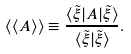Convert formula to latex. <formula><loc_0><loc_0><loc_500><loc_500>\langle \langle A \rangle \rangle \equiv \frac { \langle \tilde { \xi } | A | \tilde { \xi } \rangle } { \langle \tilde { \xi } | \tilde { \xi } \rangle } .</formula> 